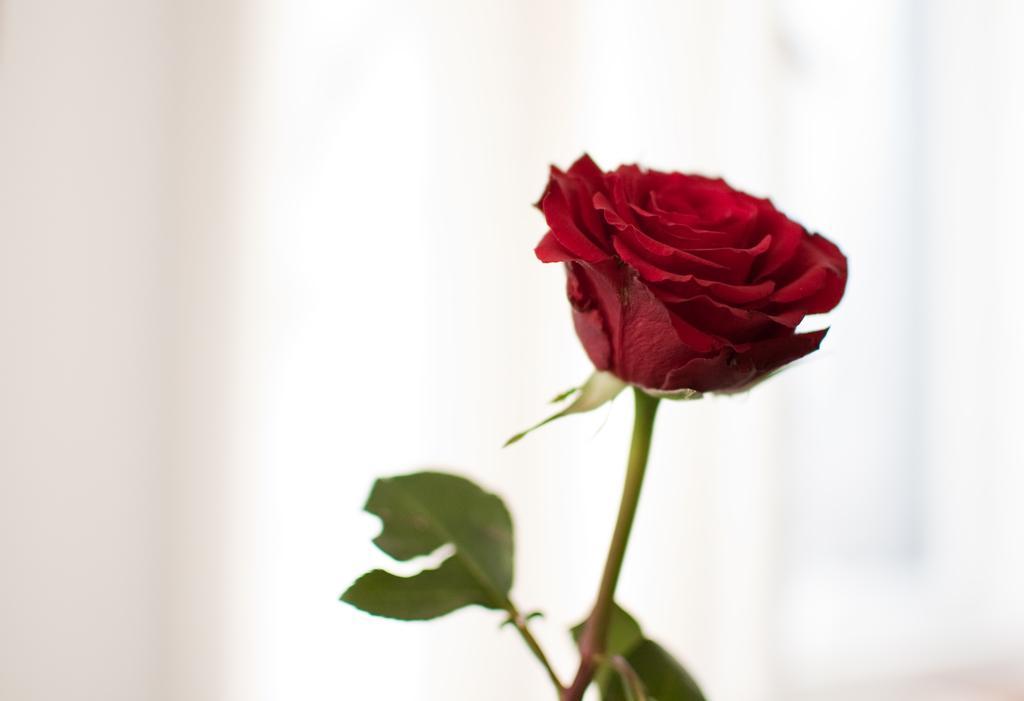Describe this image in one or two sentences. In this image there is a red color rose flower with stem and leaves. There is white color background. 